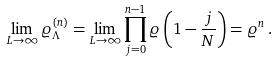<formula> <loc_0><loc_0><loc_500><loc_500>\lim _ { L \to \infty } \varrho ^ { ( n ) } _ { \Lambda } = \lim _ { L \to \infty } \prod _ { j = 0 } ^ { n - 1 } \varrho \left ( 1 - \frac { j } { N } \right ) = \varrho ^ { n } \, .</formula> 